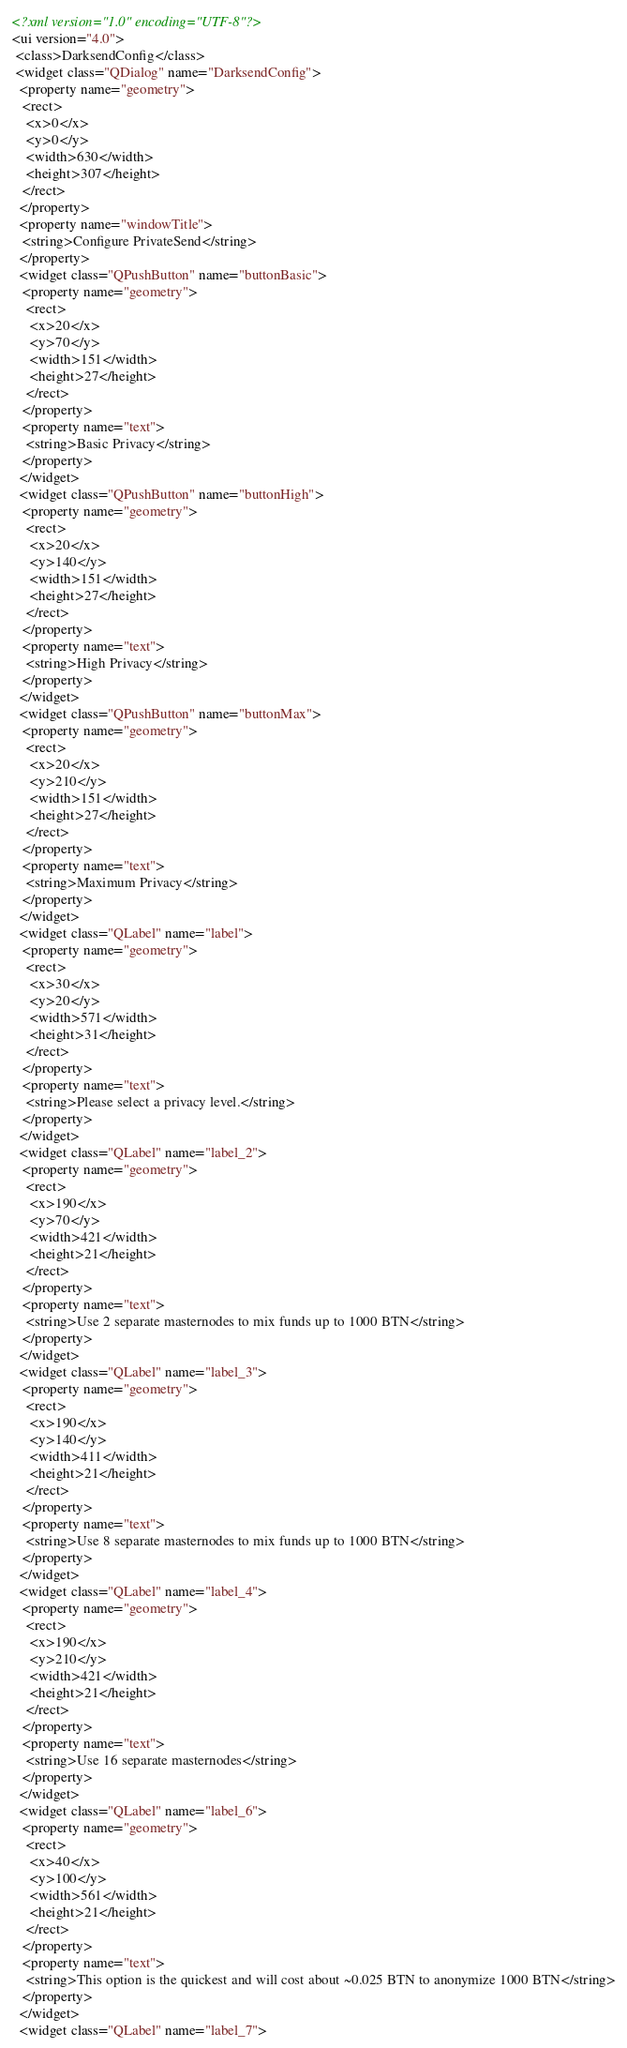Convert code to text. <code><loc_0><loc_0><loc_500><loc_500><_XML_><?xml version="1.0" encoding="UTF-8"?>
<ui version="4.0">
 <class>DarksendConfig</class>
 <widget class="QDialog" name="DarksendConfig">
  <property name="geometry">
   <rect>
    <x>0</x>
    <y>0</y>
    <width>630</width>
    <height>307</height>
   </rect>
  </property>
  <property name="windowTitle">
   <string>Configure PrivateSend</string>
  </property>
  <widget class="QPushButton" name="buttonBasic">
   <property name="geometry">
    <rect>
     <x>20</x>
     <y>70</y>
     <width>151</width>
     <height>27</height>
    </rect>
   </property>
   <property name="text">
    <string>Basic Privacy</string>
   </property>
  </widget>
  <widget class="QPushButton" name="buttonHigh">
   <property name="geometry">
    <rect>
     <x>20</x>
     <y>140</y>
     <width>151</width>
     <height>27</height>
    </rect>
   </property>
   <property name="text">
    <string>High Privacy</string>
   </property>
  </widget>
  <widget class="QPushButton" name="buttonMax">
   <property name="geometry">
    <rect>
     <x>20</x>
     <y>210</y>
     <width>151</width>
     <height>27</height>
    </rect>
   </property>
   <property name="text">
    <string>Maximum Privacy</string>
   </property>
  </widget>
  <widget class="QLabel" name="label">
   <property name="geometry">
    <rect>
     <x>30</x>
     <y>20</y>
     <width>571</width>
     <height>31</height>
    </rect>
   </property>
   <property name="text">
    <string>Please select a privacy level.</string>
   </property>
  </widget>
  <widget class="QLabel" name="label_2">
   <property name="geometry">
    <rect>
     <x>190</x>
     <y>70</y>
     <width>421</width>
     <height>21</height>
    </rect>
   </property>
   <property name="text">
    <string>Use 2 separate masternodes to mix funds up to 1000 BTN</string>
   </property>
  </widget>
  <widget class="QLabel" name="label_3">
   <property name="geometry">
    <rect>
     <x>190</x>
     <y>140</y>
     <width>411</width>
     <height>21</height>
    </rect>
   </property>
   <property name="text">
    <string>Use 8 separate masternodes to mix funds up to 1000 BTN</string>
   </property>
  </widget>
  <widget class="QLabel" name="label_4">
   <property name="geometry">
    <rect>
     <x>190</x>
     <y>210</y>
     <width>421</width>
     <height>21</height>
    </rect>
   </property>
   <property name="text">
    <string>Use 16 separate masternodes</string>
   </property>
  </widget>
  <widget class="QLabel" name="label_6">
   <property name="geometry">
    <rect>
     <x>40</x>
     <y>100</y>
     <width>561</width>
     <height>21</height>
    </rect>
   </property>
   <property name="text">
    <string>This option is the quickest and will cost about ~0.025 BTN to anonymize 1000 BTN</string>
   </property>
  </widget>
  <widget class="QLabel" name="label_7"></code> 